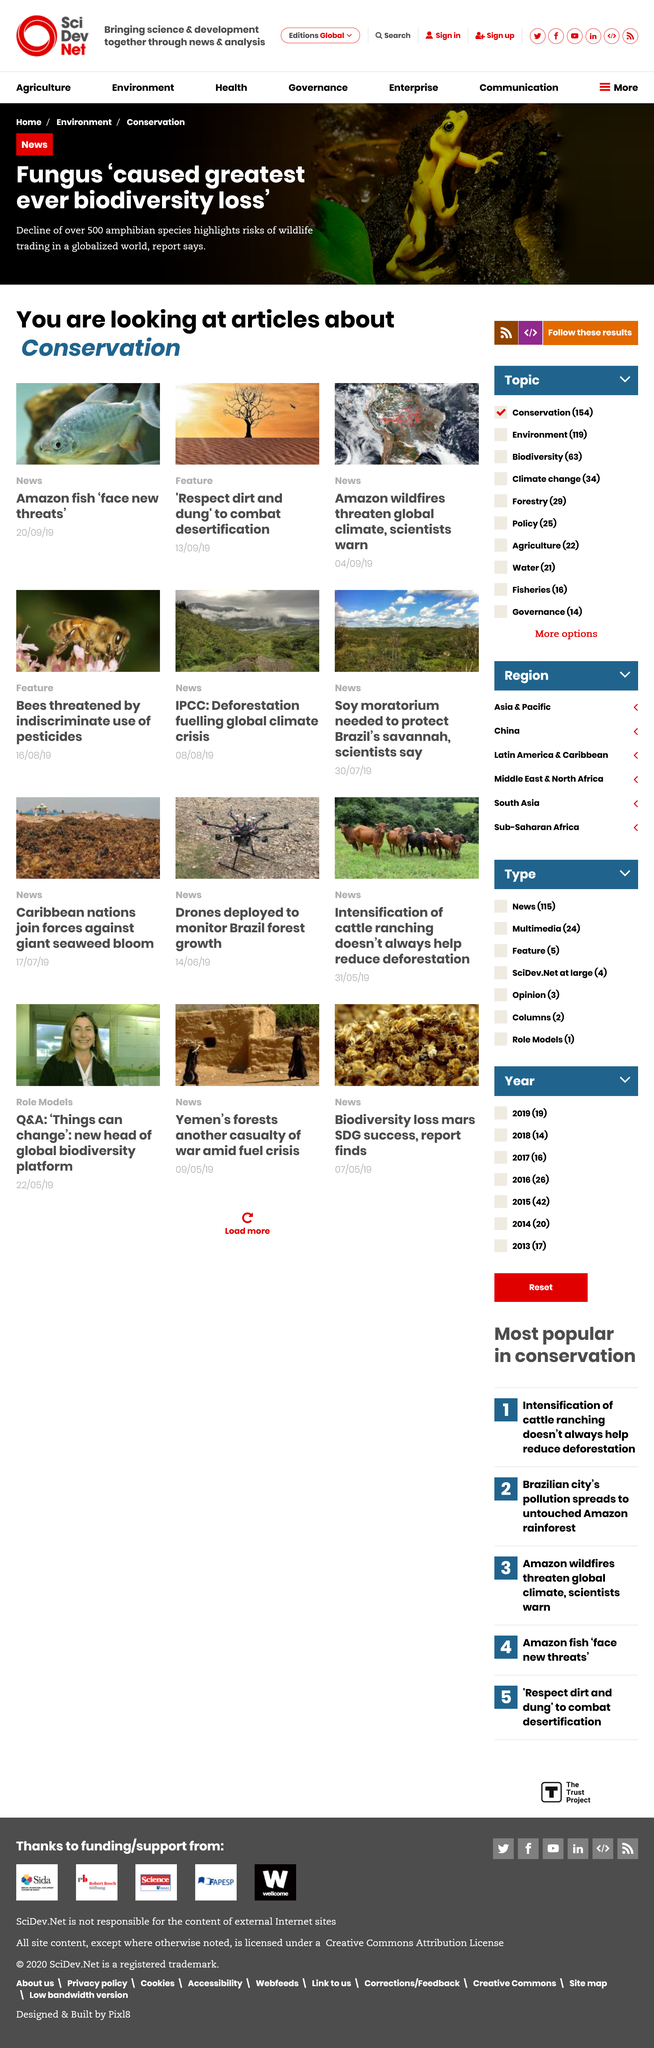Draw attention to some important aspects in this diagram. The greatest biodiversity loss in the history of the world was caused by a fungus. The articles are currently examining the topic of conservation. The page contains four attached photos. 